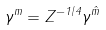<formula> <loc_0><loc_0><loc_500><loc_500>\gamma ^ { m } = Z ^ { - 1 / 4 } \gamma ^ { \hat { m } }</formula> 